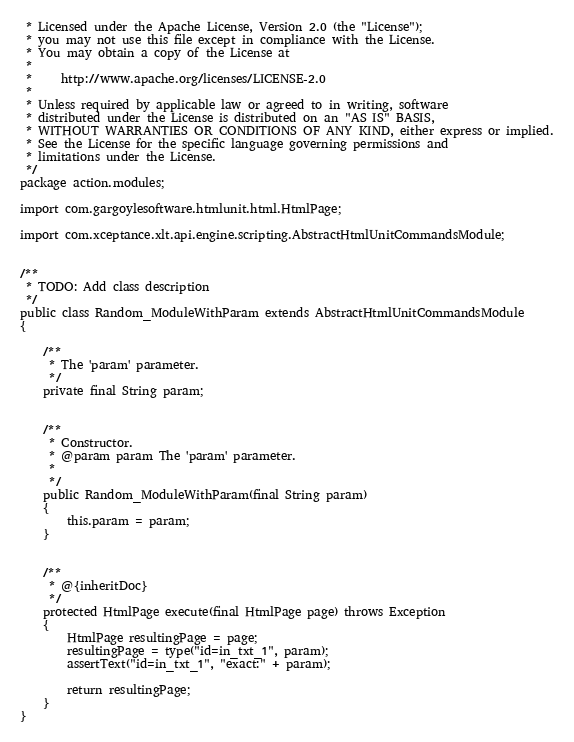<code> <loc_0><loc_0><loc_500><loc_500><_Java_> * Licensed under the Apache License, Version 2.0 (the "License");
 * you may not use this file except in compliance with the License.
 * You may obtain a copy of the License at
 *
 *     http://www.apache.org/licenses/LICENSE-2.0
 *
 * Unless required by applicable law or agreed to in writing, software
 * distributed under the License is distributed on an "AS IS" BASIS,
 * WITHOUT WARRANTIES OR CONDITIONS OF ANY KIND, either express or implied.
 * See the License for the specific language governing permissions and
 * limitations under the License.
 */
package action.modules;

import com.gargoylesoftware.htmlunit.html.HtmlPage;

import com.xceptance.xlt.api.engine.scripting.AbstractHtmlUnitCommandsModule;


/**
 * TODO: Add class description
 */
public class Random_ModuleWithParam extends AbstractHtmlUnitCommandsModule
{

    /**
     * The 'param' parameter.
     */
    private final String param;


    /**
     * Constructor.
     * @param param The 'param' parameter.
     * 
     */
    public Random_ModuleWithParam(final String param)
    {
        this.param = param;
    }


    /**
     * @{inheritDoc}
     */
    protected HtmlPage execute(final HtmlPage page) throws Exception
    {
        HtmlPage resultingPage = page;
        resultingPage = type("id=in_txt_1", param);
        assertText("id=in_txt_1", "exact:" + param);

        return resultingPage;
    }
}</code> 